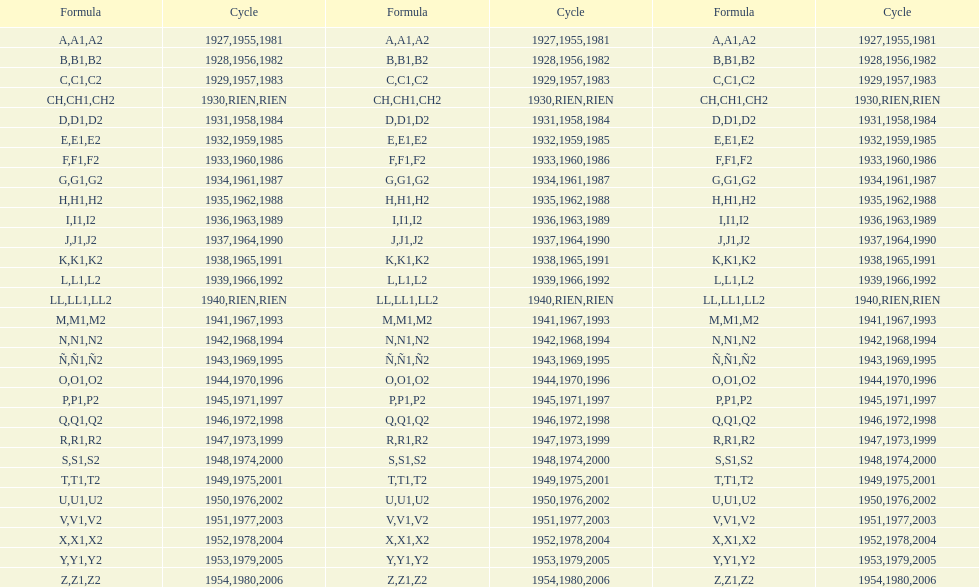How many different codes were used from 1953 to 1958? 6. 